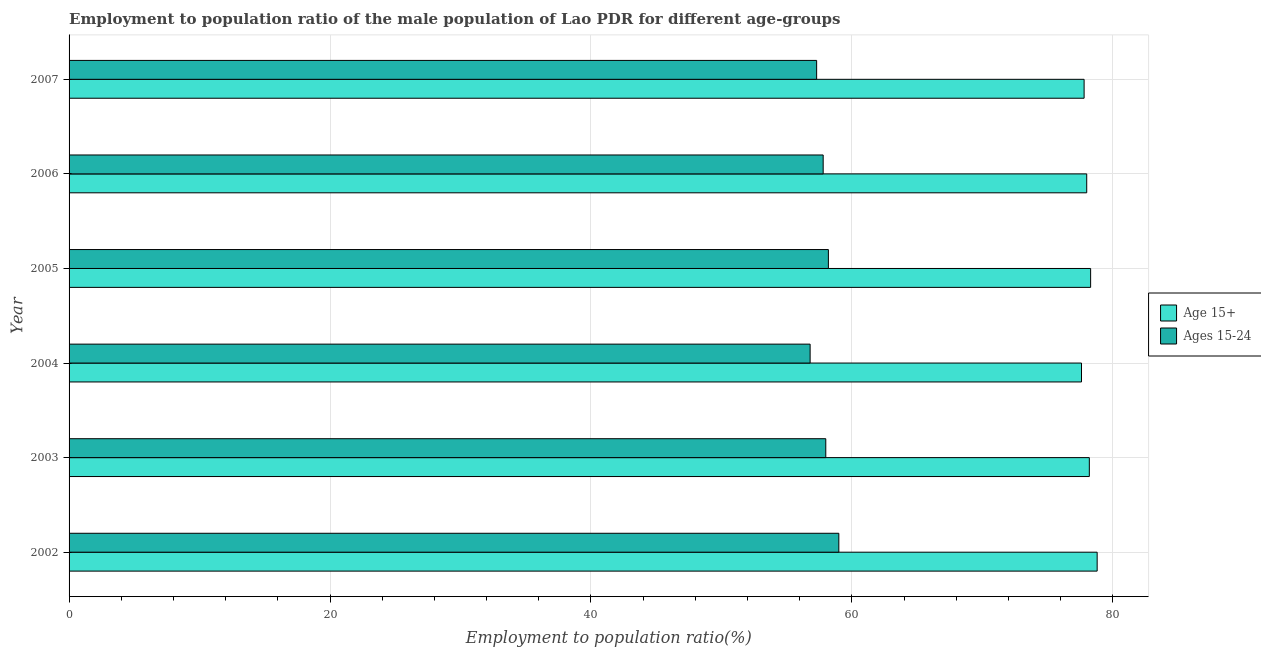How many different coloured bars are there?
Offer a terse response. 2. Are the number of bars per tick equal to the number of legend labels?
Your answer should be compact. Yes. How many bars are there on the 5th tick from the bottom?
Keep it short and to the point. 2. Across all years, what is the minimum employment to population ratio(age 15+)?
Make the answer very short. 77.6. In which year was the employment to population ratio(age 15-24) maximum?
Offer a very short reply. 2002. In which year was the employment to population ratio(age 15-24) minimum?
Your answer should be compact. 2004. What is the total employment to population ratio(age 15-24) in the graph?
Provide a succinct answer. 347.1. What is the difference between the employment to population ratio(age 15+) in 2004 and that in 2005?
Your response must be concise. -0.7. What is the difference between the employment to population ratio(age 15+) in 2002 and the employment to population ratio(age 15-24) in 2007?
Your answer should be very brief. 21.5. What is the average employment to population ratio(age 15-24) per year?
Make the answer very short. 57.85. In the year 2003, what is the difference between the employment to population ratio(age 15-24) and employment to population ratio(age 15+)?
Your answer should be compact. -20.2. In how many years, is the employment to population ratio(age 15-24) greater than 44 %?
Your answer should be very brief. 6. In how many years, is the employment to population ratio(age 15+) greater than the average employment to population ratio(age 15+) taken over all years?
Offer a very short reply. 3. What does the 1st bar from the top in 2003 represents?
Provide a succinct answer. Ages 15-24. What does the 1st bar from the bottom in 2004 represents?
Provide a succinct answer. Age 15+. How many bars are there?
Provide a short and direct response. 12. What is the difference between two consecutive major ticks on the X-axis?
Your answer should be compact. 20. Are the values on the major ticks of X-axis written in scientific E-notation?
Provide a succinct answer. No. Does the graph contain any zero values?
Offer a very short reply. No. Does the graph contain grids?
Make the answer very short. Yes. What is the title of the graph?
Keep it short and to the point. Employment to population ratio of the male population of Lao PDR for different age-groups. What is the label or title of the Y-axis?
Offer a terse response. Year. What is the Employment to population ratio(%) of Age 15+ in 2002?
Your answer should be compact. 78.8. What is the Employment to population ratio(%) in Ages 15-24 in 2002?
Provide a short and direct response. 59. What is the Employment to population ratio(%) in Age 15+ in 2003?
Ensure brevity in your answer.  78.2. What is the Employment to population ratio(%) of Age 15+ in 2004?
Offer a very short reply. 77.6. What is the Employment to population ratio(%) in Ages 15-24 in 2004?
Give a very brief answer. 56.8. What is the Employment to population ratio(%) of Age 15+ in 2005?
Your answer should be very brief. 78.3. What is the Employment to population ratio(%) of Ages 15-24 in 2005?
Your response must be concise. 58.2. What is the Employment to population ratio(%) in Ages 15-24 in 2006?
Keep it short and to the point. 57.8. What is the Employment to population ratio(%) in Age 15+ in 2007?
Give a very brief answer. 77.8. What is the Employment to population ratio(%) of Ages 15-24 in 2007?
Offer a very short reply. 57.3. Across all years, what is the maximum Employment to population ratio(%) in Age 15+?
Offer a very short reply. 78.8. Across all years, what is the minimum Employment to population ratio(%) in Age 15+?
Offer a terse response. 77.6. Across all years, what is the minimum Employment to population ratio(%) of Ages 15-24?
Your answer should be very brief. 56.8. What is the total Employment to population ratio(%) in Age 15+ in the graph?
Keep it short and to the point. 468.7. What is the total Employment to population ratio(%) in Ages 15-24 in the graph?
Your answer should be very brief. 347.1. What is the difference between the Employment to population ratio(%) of Age 15+ in 2002 and that in 2003?
Your response must be concise. 0.6. What is the difference between the Employment to population ratio(%) in Ages 15-24 in 2002 and that in 2004?
Offer a very short reply. 2.2. What is the difference between the Employment to population ratio(%) of Ages 15-24 in 2002 and that in 2006?
Make the answer very short. 1.2. What is the difference between the Employment to population ratio(%) in Ages 15-24 in 2002 and that in 2007?
Your answer should be very brief. 1.7. What is the difference between the Employment to population ratio(%) in Age 15+ in 2003 and that in 2007?
Offer a very short reply. 0.4. What is the difference between the Employment to population ratio(%) in Ages 15-24 in 2003 and that in 2007?
Ensure brevity in your answer.  0.7. What is the difference between the Employment to population ratio(%) in Age 15+ in 2004 and that in 2006?
Your answer should be very brief. -0.4. What is the difference between the Employment to population ratio(%) in Ages 15-24 in 2004 and that in 2007?
Your answer should be very brief. -0.5. What is the difference between the Employment to population ratio(%) of Ages 15-24 in 2005 and that in 2006?
Ensure brevity in your answer.  0.4. What is the difference between the Employment to population ratio(%) of Age 15+ in 2005 and that in 2007?
Your answer should be compact. 0.5. What is the difference between the Employment to population ratio(%) in Ages 15-24 in 2006 and that in 2007?
Offer a terse response. 0.5. What is the difference between the Employment to population ratio(%) in Age 15+ in 2002 and the Employment to population ratio(%) in Ages 15-24 in 2003?
Provide a short and direct response. 20.8. What is the difference between the Employment to population ratio(%) in Age 15+ in 2002 and the Employment to population ratio(%) in Ages 15-24 in 2004?
Make the answer very short. 22. What is the difference between the Employment to population ratio(%) of Age 15+ in 2002 and the Employment to population ratio(%) of Ages 15-24 in 2005?
Your answer should be very brief. 20.6. What is the difference between the Employment to population ratio(%) of Age 15+ in 2002 and the Employment to population ratio(%) of Ages 15-24 in 2006?
Provide a succinct answer. 21. What is the difference between the Employment to population ratio(%) in Age 15+ in 2003 and the Employment to population ratio(%) in Ages 15-24 in 2004?
Ensure brevity in your answer.  21.4. What is the difference between the Employment to population ratio(%) of Age 15+ in 2003 and the Employment to population ratio(%) of Ages 15-24 in 2005?
Offer a very short reply. 20. What is the difference between the Employment to population ratio(%) of Age 15+ in 2003 and the Employment to population ratio(%) of Ages 15-24 in 2006?
Offer a very short reply. 20.4. What is the difference between the Employment to population ratio(%) of Age 15+ in 2003 and the Employment to population ratio(%) of Ages 15-24 in 2007?
Offer a terse response. 20.9. What is the difference between the Employment to population ratio(%) of Age 15+ in 2004 and the Employment to population ratio(%) of Ages 15-24 in 2006?
Your answer should be very brief. 19.8. What is the difference between the Employment to population ratio(%) of Age 15+ in 2004 and the Employment to population ratio(%) of Ages 15-24 in 2007?
Keep it short and to the point. 20.3. What is the difference between the Employment to population ratio(%) in Age 15+ in 2005 and the Employment to population ratio(%) in Ages 15-24 in 2007?
Provide a short and direct response. 21. What is the difference between the Employment to population ratio(%) in Age 15+ in 2006 and the Employment to population ratio(%) in Ages 15-24 in 2007?
Your answer should be very brief. 20.7. What is the average Employment to population ratio(%) of Age 15+ per year?
Provide a succinct answer. 78.12. What is the average Employment to population ratio(%) of Ages 15-24 per year?
Keep it short and to the point. 57.85. In the year 2002, what is the difference between the Employment to population ratio(%) in Age 15+ and Employment to population ratio(%) in Ages 15-24?
Offer a terse response. 19.8. In the year 2003, what is the difference between the Employment to population ratio(%) in Age 15+ and Employment to population ratio(%) in Ages 15-24?
Your answer should be very brief. 20.2. In the year 2004, what is the difference between the Employment to population ratio(%) in Age 15+ and Employment to population ratio(%) in Ages 15-24?
Provide a short and direct response. 20.8. In the year 2005, what is the difference between the Employment to population ratio(%) of Age 15+ and Employment to population ratio(%) of Ages 15-24?
Keep it short and to the point. 20.1. In the year 2006, what is the difference between the Employment to population ratio(%) of Age 15+ and Employment to population ratio(%) of Ages 15-24?
Keep it short and to the point. 20.2. What is the ratio of the Employment to population ratio(%) in Age 15+ in 2002 to that in 2003?
Offer a very short reply. 1.01. What is the ratio of the Employment to population ratio(%) of Ages 15-24 in 2002 to that in 2003?
Your response must be concise. 1.02. What is the ratio of the Employment to population ratio(%) of Age 15+ in 2002 to that in 2004?
Offer a terse response. 1.02. What is the ratio of the Employment to population ratio(%) of Ages 15-24 in 2002 to that in 2004?
Your answer should be very brief. 1.04. What is the ratio of the Employment to population ratio(%) of Age 15+ in 2002 to that in 2005?
Keep it short and to the point. 1.01. What is the ratio of the Employment to population ratio(%) in Ages 15-24 in 2002 to that in 2005?
Offer a terse response. 1.01. What is the ratio of the Employment to population ratio(%) of Age 15+ in 2002 to that in 2006?
Keep it short and to the point. 1.01. What is the ratio of the Employment to population ratio(%) in Ages 15-24 in 2002 to that in 2006?
Keep it short and to the point. 1.02. What is the ratio of the Employment to population ratio(%) of Age 15+ in 2002 to that in 2007?
Your response must be concise. 1.01. What is the ratio of the Employment to population ratio(%) in Ages 15-24 in 2002 to that in 2007?
Ensure brevity in your answer.  1.03. What is the ratio of the Employment to population ratio(%) in Age 15+ in 2003 to that in 2004?
Offer a very short reply. 1.01. What is the ratio of the Employment to population ratio(%) in Ages 15-24 in 2003 to that in 2004?
Make the answer very short. 1.02. What is the ratio of the Employment to population ratio(%) of Ages 15-24 in 2003 to that in 2005?
Give a very brief answer. 1. What is the ratio of the Employment to population ratio(%) in Ages 15-24 in 2003 to that in 2007?
Offer a terse response. 1.01. What is the ratio of the Employment to population ratio(%) in Ages 15-24 in 2004 to that in 2005?
Ensure brevity in your answer.  0.98. What is the ratio of the Employment to population ratio(%) in Age 15+ in 2004 to that in 2006?
Your response must be concise. 0.99. What is the ratio of the Employment to population ratio(%) of Ages 15-24 in 2004 to that in 2006?
Provide a short and direct response. 0.98. What is the ratio of the Employment to population ratio(%) in Age 15+ in 2005 to that in 2007?
Make the answer very short. 1.01. What is the ratio of the Employment to population ratio(%) of Ages 15-24 in 2005 to that in 2007?
Your answer should be compact. 1.02. What is the ratio of the Employment to population ratio(%) of Age 15+ in 2006 to that in 2007?
Your answer should be very brief. 1. What is the ratio of the Employment to population ratio(%) in Ages 15-24 in 2006 to that in 2007?
Make the answer very short. 1.01. What is the difference between the highest and the lowest Employment to population ratio(%) in Age 15+?
Make the answer very short. 1.2. What is the difference between the highest and the lowest Employment to population ratio(%) of Ages 15-24?
Ensure brevity in your answer.  2.2. 